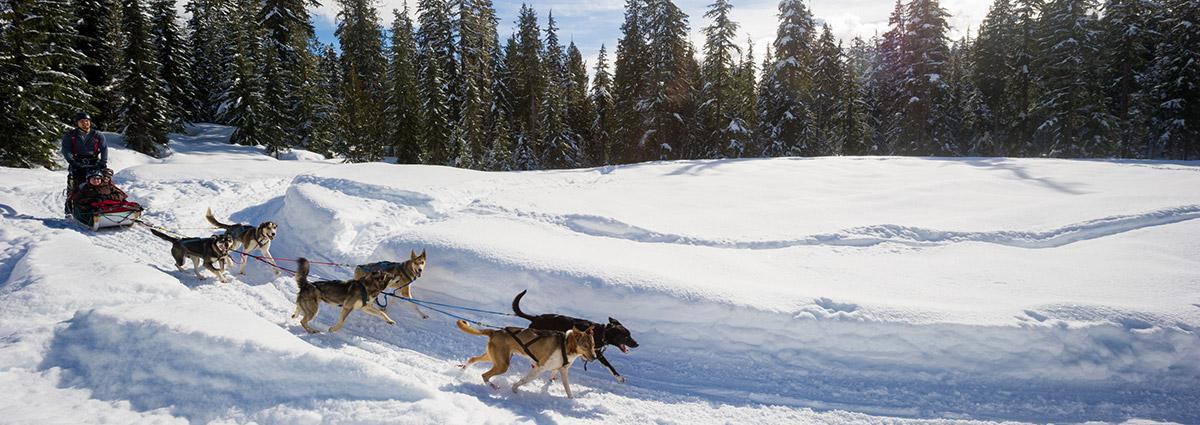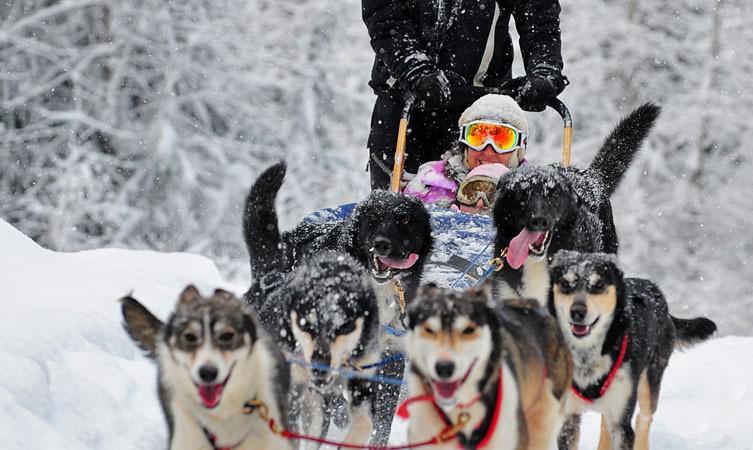The first image is the image on the left, the second image is the image on the right. For the images displayed, is the sentence "In one image, the sled driver wears a bright red jacket." factually correct? Answer yes or no. No. The first image is the image on the left, the second image is the image on the right. Analyze the images presented: Is the assertion "There is a person in a red coat in the image on the right." valid? Answer yes or no. No. 